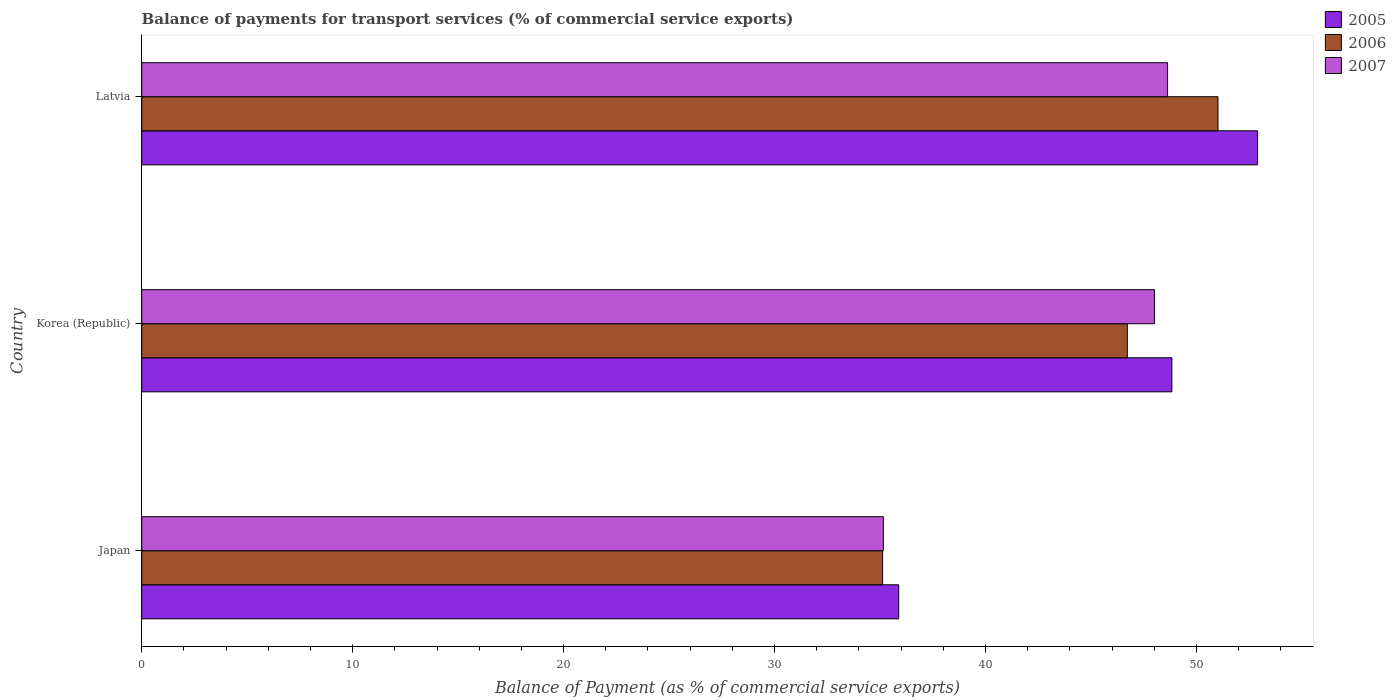Are the number of bars on each tick of the Y-axis equal?
Give a very brief answer. Yes. What is the balance of payments for transport services in 2007 in Latvia?
Keep it short and to the point. 48.63. Across all countries, what is the maximum balance of payments for transport services in 2006?
Keep it short and to the point. 51.02. Across all countries, what is the minimum balance of payments for transport services in 2006?
Your answer should be very brief. 35.12. In which country was the balance of payments for transport services in 2006 maximum?
Your response must be concise. Latvia. What is the total balance of payments for transport services in 2007 in the graph?
Provide a short and direct response. 131.8. What is the difference between the balance of payments for transport services in 2006 in Japan and that in Latvia?
Keep it short and to the point. -15.9. What is the difference between the balance of payments for transport services in 2007 in Japan and the balance of payments for transport services in 2005 in Latvia?
Provide a short and direct response. -17.74. What is the average balance of payments for transport services in 2005 per country?
Your answer should be very brief. 45.87. What is the difference between the balance of payments for transport services in 2007 and balance of payments for transport services in 2006 in Latvia?
Keep it short and to the point. -2.39. What is the ratio of the balance of payments for transport services in 2007 in Japan to that in Latvia?
Provide a succinct answer. 0.72. What is the difference between the highest and the second highest balance of payments for transport services in 2007?
Offer a very short reply. 0.62. What is the difference between the highest and the lowest balance of payments for transport services in 2005?
Give a very brief answer. 17.01. What does the 2nd bar from the bottom in Korea (Republic) represents?
Provide a short and direct response. 2006. Are all the bars in the graph horizontal?
Give a very brief answer. Yes. What is the difference between two consecutive major ticks on the X-axis?
Offer a terse response. 10. Are the values on the major ticks of X-axis written in scientific E-notation?
Offer a very short reply. No. Does the graph contain grids?
Keep it short and to the point. No. Where does the legend appear in the graph?
Your response must be concise. Top right. How many legend labels are there?
Offer a terse response. 3. How are the legend labels stacked?
Provide a short and direct response. Vertical. What is the title of the graph?
Offer a terse response. Balance of payments for transport services (% of commercial service exports). What is the label or title of the X-axis?
Keep it short and to the point. Balance of Payment (as % of commercial service exports). What is the label or title of the Y-axis?
Keep it short and to the point. Country. What is the Balance of Payment (as % of commercial service exports) in 2005 in Japan?
Make the answer very short. 35.89. What is the Balance of Payment (as % of commercial service exports) in 2006 in Japan?
Ensure brevity in your answer.  35.12. What is the Balance of Payment (as % of commercial service exports) in 2007 in Japan?
Offer a terse response. 35.16. What is the Balance of Payment (as % of commercial service exports) of 2005 in Korea (Republic)?
Your answer should be very brief. 48.84. What is the Balance of Payment (as % of commercial service exports) of 2006 in Korea (Republic)?
Your response must be concise. 46.72. What is the Balance of Payment (as % of commercial service exports) in 2007 in Korea (Republic)?
Give a very brief answer. 48.01. What is the Balance of Payment (as % of commercial service exports) of 2005 in Latvia?
Provide a succinct answer. 52.9. What is the Balance of Payment (as % of commercial service exports) in 2006 in Latvia?
Offer a terse response. 51.02. What is the Balance of Payment (as % of commercial service exports) in 2007 in Latvia?
Give a very brief answer. 48.63. Across all countries, what is the maximum Balance of Payment (as % of commercial service exports) of 2005?
Your answer should be compact. 52.9. Across all countries, what is the maximum Balance of Payment (as % of commercial service exports) of 2006?
Offer a very short reply. 51.02. Across all countries, what is the maximum Balance of Payment (as % of commercial service exports) of 2007?
Ensure brevity in your answer.  48.63. Across all countries, what is the minimum Balance of Payment (as % of commercial service exports) in 2005?
Your answer should be very brief. 35.89. Across all countries, what is the minimum Balance of Payment (as % of commercial service exports) in 2006?
Provide a short and direct response. 35.12. Across all countries, what is the minimum Balance of Payment (as % of commercial service exports) in 2007?
Give a very brief answer. 35.16. What is the total Balance of Payment (as % of commercial service exports) of 2005 in the graph?
Your answer should be very brief. 137.62. What is the total Balance of Payment (as % of commercial service exports) in 2006 in the graph?
Provide a short and direct response. 132.87. What is the total Balance of Payment (as % of commercial service exports) of 2007 in the graph?
Your response must be concise. 131.8. What is the difference between the Balance of Payment (as % of commercial service exports) in 2005 in Japan and that in Korea (Republic)?
Your response must be concise. -12.95. What is the difference between the Balance of Payment (as % of commercial service exports) of 2006 in Japan and that in Korea (Republic)?
Keep it short and to the point. -11.6. What is the difference between the Balance of Payment (as % of commercial service exports) of 2007 in Japan and that in Korea (Republic)?
Offer a terse response. -12.85. What is the difference between the Balance of Payment (as % of commercial service exports) of 2005 in Japan and that in Latvia?
Your answer should be compact. -17.01. What is the difference between the Balance of Payment (as % of commercial service exports) in 2006 in Japan and that in Latvia?
Provide a succinct answer. -15.9. What is the difference between the Balance of Payment (as % of commercial service exports) in 2007 in Japan and that in Latvia?
Ensure brevity in your answer.  -13.47. What is the difference between the Balance of Payment (as % of commercial service exports) of 2005 in Korea (Republic) and that in Latvia?
Keep it short and to the point. -4.06. What is the difference between the Balance of Payment (as % of commercial service exports) in 2006 in Korea (Republic) and that in Latvia?
Give a very brief answer. -4.3. What is the difference between the Balance of Payment (as % of commercial service exports) in 2007 in Korea (Republic) and that in Latvia?
Your answer should be very brief. -0.62. What is the difference between the Balance of Payment (as % of commercial service exports) in 2005 in Japan and the Balance of Payment (as % of commercial service exports) in 2006 in Korea (Republic)?
Ensure brevity in your answer.  -10.84. What is the difference between the Balance of Payment (as % of commercial service exports) of 2005 in Japan and the Balance of Payment (as % of commercial service exports) of 2007 in Korea (Republic)?
Your answer should be compact. -12.12. What is the difference between the Balance of Payment (as % of commercial service exports) of 2006 in Japan and the Balance of Payment (as % of commercial service exports) of 2007 in Korea (Republic)?
Make the answer very short. -12.89. What is the difference between the Balance of Payment (as % of commercial service exports) in 2005 in Japan and the Balance of Payment (as % of commercial service exports) in 2006 in Latvia?
Provide a short and direct response. -15.14. What is the difference between the Balance of Payment (as % of commercial service exports) in 2005 in Japan and the Balance of Payment (as % of commercial service exports) in 2007 in Latvia?
Your response must be concise. -12.75. What is the difference between the Balance of Payment (as % of commercial service exports) of 2006 in Japan and the Balance of Payment (as % of commercial service exports) of 2007 in Latvia?
Keep it short and to the point. -13.51. What is the difference between the Balance of Payment (as % of commercial service exports) in 2005 in Korea (Republic) and the Balance of Payment (as % of commercial service exports) in 2006 in Latvia?
Ensure brevity in your answer.  -2.19. What is the difference between the Balance of Payment (as % of commercial service exports) in 2005 in Korea (Republic) and the Balance of Payment (as % of commercial service exports) in 2007 in Latvia?
Offer a very short reply. 0.2. What is the difference between the Balance of Payment (as % of commercial service exports) in 2006 in Korea (Republic) and the Balance of Payment (as % of commercial service exports) in 2007 in Latvia?
Your answer should be compact. -1.91. What is the average Balance of Payment (as % of commercial service exports) in 2005 per country?
Keep it short and to the point. 45.87. What is the average Balance of Payment (as % of commercial service exports) in 2006 per country?
Offer a terse response. 44.29. What is the average Balance of Payment (as % of commercial service exports) in 2007 per country?
Your answer should be very brief. 43.93. What is the difference between the Balance of Payment (as % of commercial service exports) in 2005 and Balance of Payment (as % of commercial service exports) in 2006 in Japan?
Offer a very short reply. 0.76. What is the difference between the Balance of Payment (as % of commercial service exports) of 2005 and Balance of Payment (as % of commercial service exports) of 2007 in Japan?
Offer a very short reply. 0.73. What is the difference between the Balance of Payment (as % of commercial service exports) in 2006 and Balance of Payment (as % of commercial service exports) in 2007 in Japan?
Ensure brevity in your answer.  -0.03. What is the difference between the Balance of Payment (as % of commercial service exports) of 2005 and Balance of Payment (as % of commercial service exports) of 2006 in Korea (Republic)?
Your answer should be very brief. 2.11. What is the difference between the Balance of Payment (as % of commercial service exports) of 2005 and Balance of Payment (as % of commercial service exports) of 2007 in Korea (Republic)?
Ensure brevity in your answer.  0.83. What is the difference between the Balance of Payment (as % of commercial service exports) of 2006 and Balance of Payment (as % of commercial service exports) of 2007 in Korea (Republic)?
Provide a short and direct response. -1.29. What is the difference between the Balance of Payment (as % of commercial service exports) of 2005 and Balance of Payment (as % of commercial service exports) of 2006 in Latvia?
Provide a short and direct response. 1.88. What is the difference between the Balance of Payment (as % of commercial service exports) in 2005 and Balance of Payment (as % of commercial service exports) in 2007 in Latvia?
Ensure brevity in your answer.  4.27. What is the difference between the Balance of Payment (as % of commercial service exports) in 2006 and Balance of Payment (as % of commercial service exports) in 2007 in Latvia?
Your response must be concise. 2.39. What is the ratio of the Balance of Payment (as % of commercial service exports) of 2005 in Japan to that in Korea (Republic)?
Give a very brief answer. 0.73. What is the ratio of the Balance of Payment (as % of commercial service exports) of 2006 in Japan to that in Korea (Republic)?
Ensure brevity in your answer.  0.75. What is the ratio of the Balance of Payment (as % of commercial service exports) of 2007 in Japan to that in Korea (Republic)?
Give a very brief answer. 0.73. What is the ratio of the Balance of Payment (as % of commercial service exports) in 2005 in Japan to that in Latvia?
Ensure brevity in your answer.  0.68. What is the ratio of the Balance of Payment (as % of commercial service exports) of 2006 in Japan to that in Latvia?
Provide a short and direct response. 0.69. What is the ratio of the Balance of Payment (as % of commercial service exports) of 2007 in Japan to that in Latvia?
Your answer should be very brief. 0.72. What is the ratio of the Balance of Payment (as % of commercial service exports) of 2005 in Korea (Republic) to that in Latvia?
Your answer should be very brief. 0.92. What is the ratio of the Balance of Payment (as % of commercial service exports) of 2006 in Korea (Republic) to that in Latvia?
Make the answer very short. 0.92. What is the ratio of the Balance of Payment (as % of commercial service exports) in 2007 in Korea (Republic) to that in Latvia?
Offer a very short reply. 0.99. What is the difference between the highest and the second highest Balance of Payment (as % of commercial service exports) in 2005?
Offer a terse response. 4.06. What is the difference between the highest and the second highest Balance of Payment (as % of commercial service exports) of 2006?
Offer a terse response. 4.3. What is the difference between the highest and the second highest Balance of Payment (as % of commercial service exports) of 2007?
Make the answer very short. 0.62. What is the difference between the highest and the lowest Balance of Payment (as % of commercial service exports) in 2005?
Provide a short and direct response. 17.01. What is the difference between the highest and the lowest Balance of Payment (as % of commercial service exports) in 2006?
Provide a short and direct response. 15.9. What is the difference between the highest and the lowest Balance of Payment (as % of commercial service exports) of 2007?
Offer a very short reply. 13.47. 